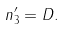Convert formula to latex. <formula><loc_0><loc_0><loc_500><loc_500>n _ { 3 } ^ { \prime } = { D } .</formula> 